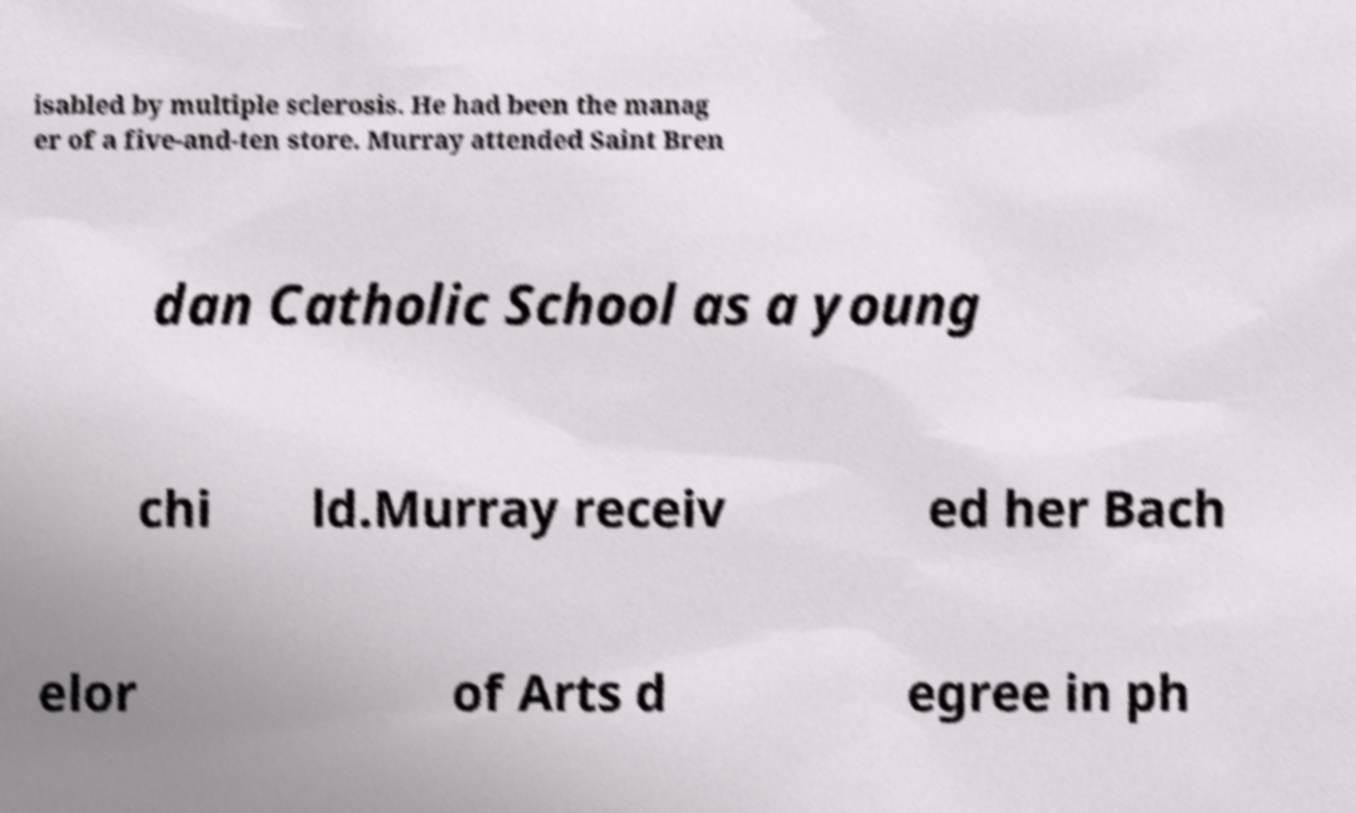Can you read and provide the text displayed in the image?This photo seems to have some interesting text. Can you extract and type it out for me? isabled by multiple sclerosis. He had been the manag er of a five-and-ten store. Murray attended Saint Bren dan Catholic School as a young chi ld.Murray receiv ed her Bach elor of Arts d egree in ph 